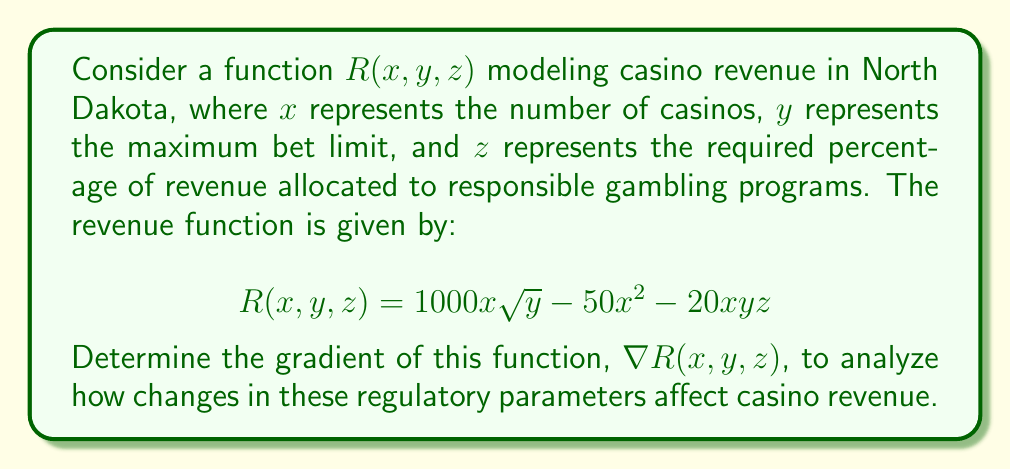Teach me how to tackle this problem. To find the gradient of the function $R(x, y, z)$, we need to calculate the partial derivatives with respect to each variable:

1. Partial derivative with respect to $x$:
   $$\frac{\partial R}{\partial x} = 1000\sqrt{y} - 100x - 20yz$$

2. Partial derivative with respect to $y$:
   $$\frac{\partial R}{\partial y} = 1000x \cdot \frac{1}{2\sqrt{y}} - 20xz = \frac{500x}{\sqrt{y}} - 20xz$$

3. Partial derivative with respect to $z$:
   $$\frac{\partial R}{\partial z} = -20xy$$

The gradient is a vector-valued function that combines these partial derivatives:

$$\nabla R(x, y, z) = \left(\frac{\partial R}{\partial x}, \frac{\partial R}{\partial y}, \frac{\partial R}{\partial z}\right)$$

Substituting the calculated partial derivatives:

$$\nabla R(x, y, z) = \left(1000\sqrt{y} - 100x - 20yz, \frac{500x}{\sqrt{y}} - 20xz, -20xy\right)$$

This gradient vector represents the direction of steepest increase in casino revenue with respect to changes in the number of casinos, maximum bet limit, and responsible gambling program allocation.
Answer: $$\nabla R(x, y, z) = \left(1000\sqrt{y} - 100x - 20yz, \frac{500x}{\sqrt{y}} - 20xz, -20xy\right)$$ 